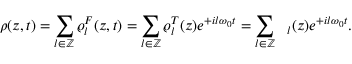<formula> <loc_0><loc_0><loc_500><loc_500>\rho ( z , t ) = \sum _ { l \in \mathbb { Z } } \varrho _ { l } ^ { F } ( z , t ) = \sum _ { l \in \mathbb { Z } } \varrho _ { l } ^ { T } ( z ) e ^ { + i l \omega _ { 0 } t } = \sum _ { l \in \mathbb { Z } } \xi _ { l } ( z ) e ^ { + i l \omega _ { 0 } t } .</formula> 